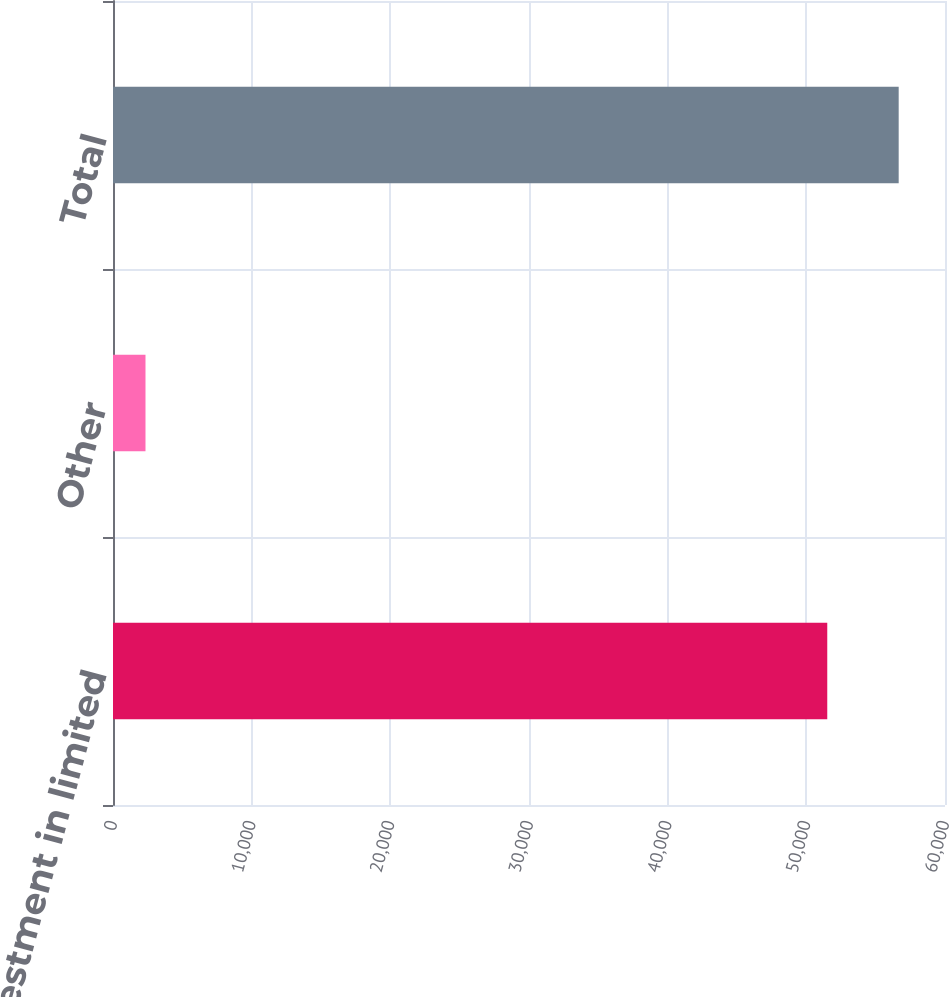<chart> <loc_0><loc_0><loc_500><loc_500><bar_chart><fcel>Investment in limited<fcel>Other<fcel>Total<nl><fcel>51509<fcel>2343<fcel>56659.9<nl></chart> 